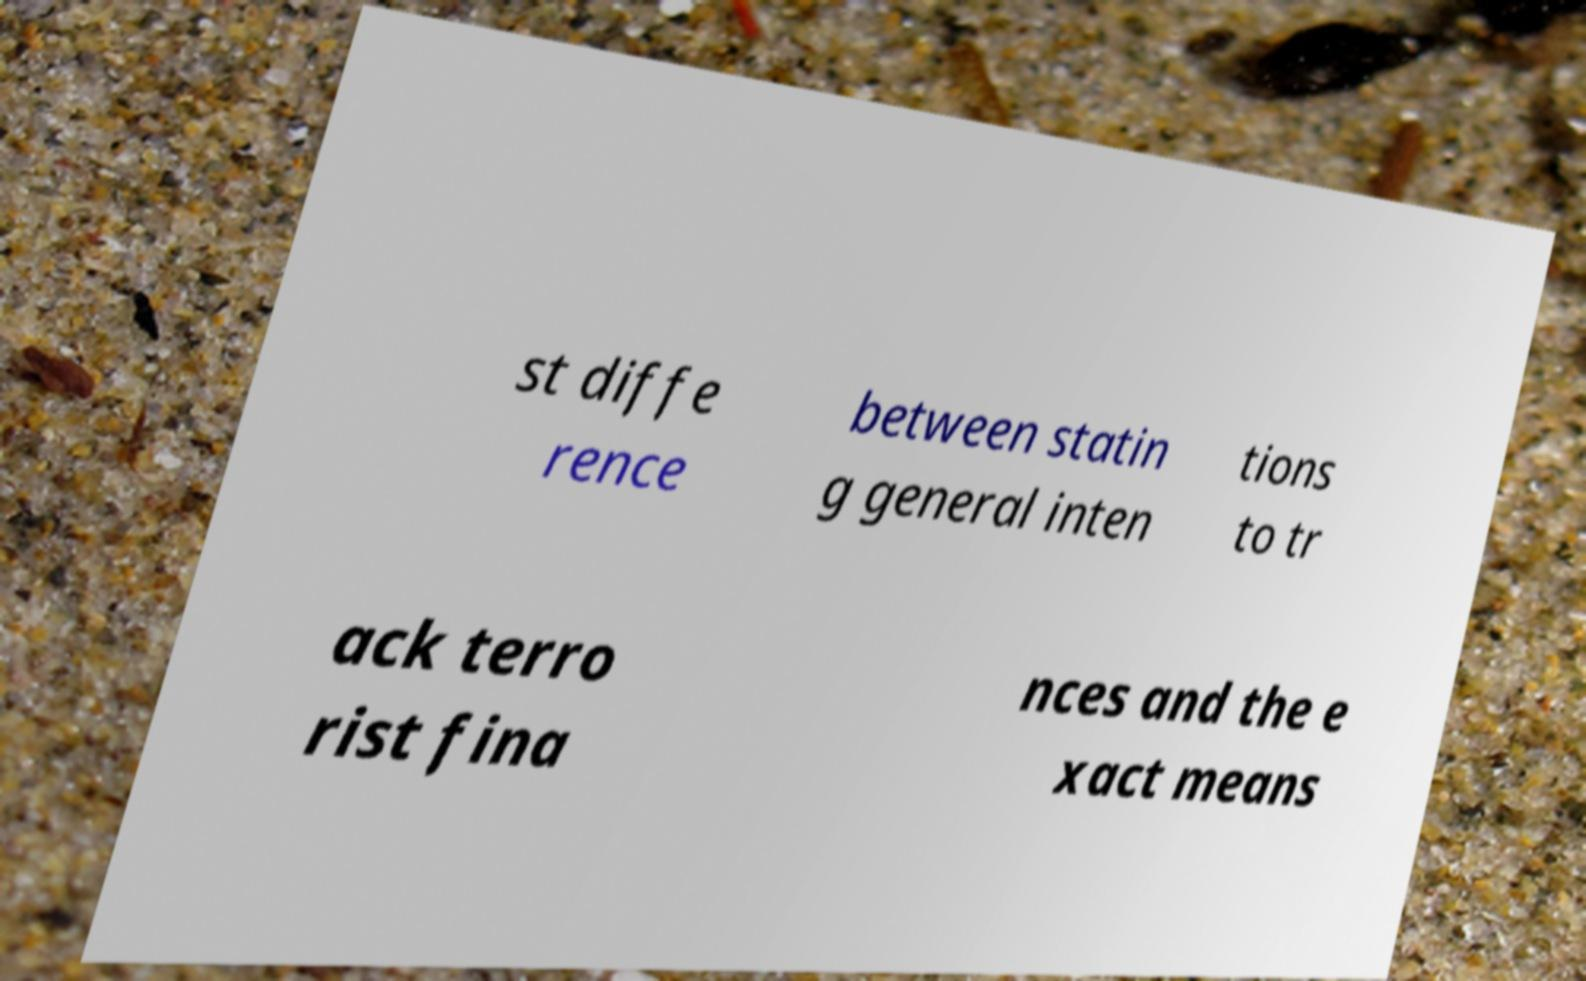Please read and relay the text visible in this image. What does it say? st diffe rence between statin g general inten tions to tr ack terro rist fina nces and the e xact means 